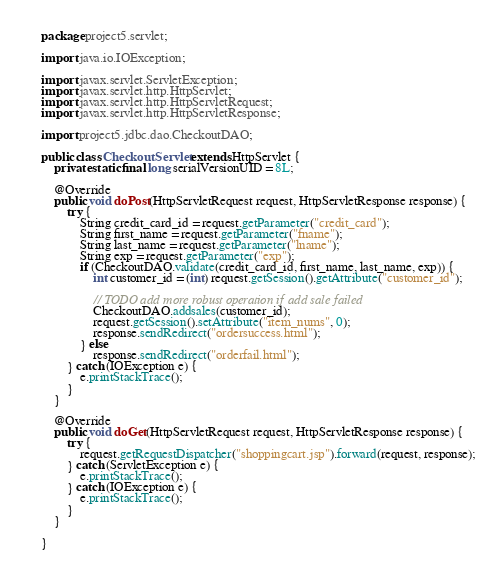Convert code to text. <code><loc_0><loc_0><loc_500><loc_500><_Java_>package project5.servlet;

import java.io.IOException;

import javax.servlet.ServletException;
import javax.servlet.http.HttpServlet;
import javax.servlet.http.HttpServletRequest;
import javax.servlet.http.HttpServletResponse;

import project5.jdbc.dao.CheckoutDAO;

public class CheckoutServlet extends HttpServlet {
	private static final long serialVersionUID = 8L;

	@Override
	public void doPost(HttpServletRequest request, HttpServletResponse response) {
		try {
			String credit_card_id = request.getParameter("credit_card");
			String first_name = request.getParameter("fname");
			String last_name = request.getParameter("lname");
			String exp = request.getParameter("exp");
			if (CheckoutDAO.validate(credit_card_id, first_name, last_name, exp)) {
				int customer_id = (int) request.getSession().getAttribute("customer_id");

				// TODO add more robust operation if add sale failed
				CheckoutDAO.addsales(customer_id);
				request.getSession().setAttribute("item_nums", 0);
				response.sendRedirect("ordersuccess.html");
			} else
				response.sendRedirect("orderfail.html");
		} catch (IOException e) {
			e.printStackTrace();
		}
	}

	@Override
	public void doGet(HttpServletRequest request, HttpServletResponse response) {
		try {
			request.getRequestDispatcher("shoppingcart.jsp").forward(request, response);
		} catch (ServletException e) {
			e.printStackTrace();
		} catch (IOException e) {
			e.printStackTrace();
		}
	}

}
</code> 